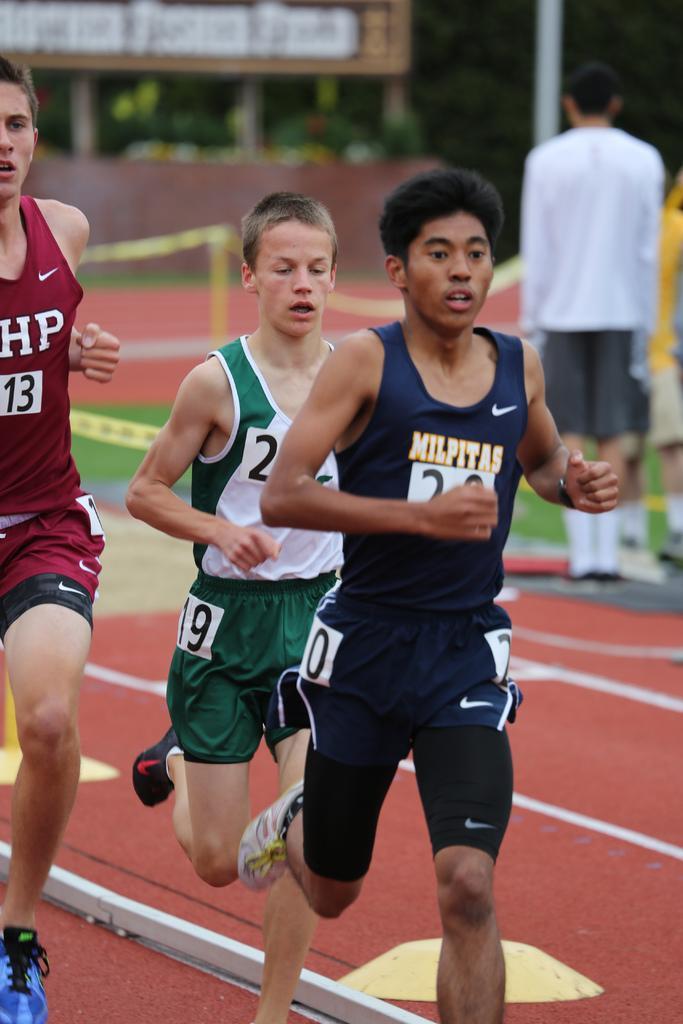Can you describe this image briefly? In this images few men are running on the ground. In the background we can see caution tape, hoarding, trees, poles and few persons are standing on the ground on the right side. 